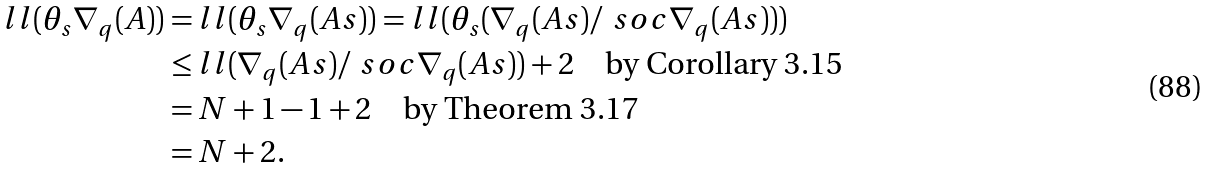<formula> <loc_0><loc_0><loc_500><loc_500>l l ( \theta _ { s } \nabla _ { q } ( A ) ) & = l l ( \theta _ { s } \nabla _ { q } ( A s ) ) = l l ( \theta _ { s } ( \nabla _ { q } ( A s ) / \ s o c \nabla _ { q } ( A s ) ) ) \\ & \leq l l ( \nabla _ { q } ( A s ) / \ s o c \nabla _ { q } ( A s ) ) + 2 \quad \text {by Corollary 3.15} \\ & = N + 1 - 1 + 2 \quad \text {by Theorem 3.17} \\ & = N + 2 .</formula> 